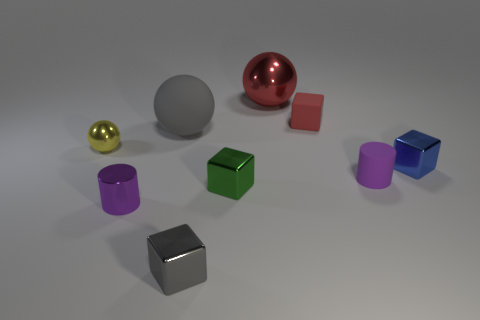Subtract 1 blocks. How many blocks are left? 3 Add 1 yellow rubber cubes. How many objects exist? 10 Subtract all cylinders. How many objects are left? 7 Subtract all brown matte spheres. Subtract all small matte objects. How many objects are left? 7 Add 5 blue blocks. How many blue blocks are left? 6 Add 7 purple matte cylinders. How many purple matte cylinders exist? 8 Subtract 0 brown cylinders. How many objects are left? 9 